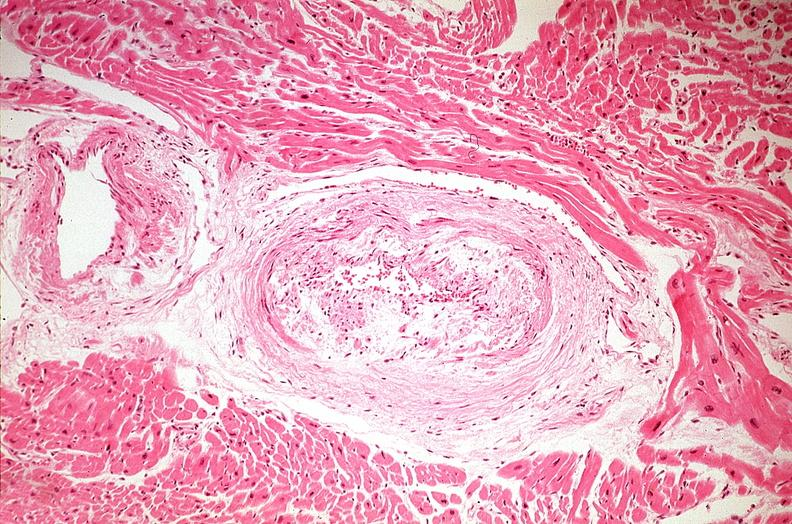where is this from?
Answer the question using a single word or phrase. Heart 